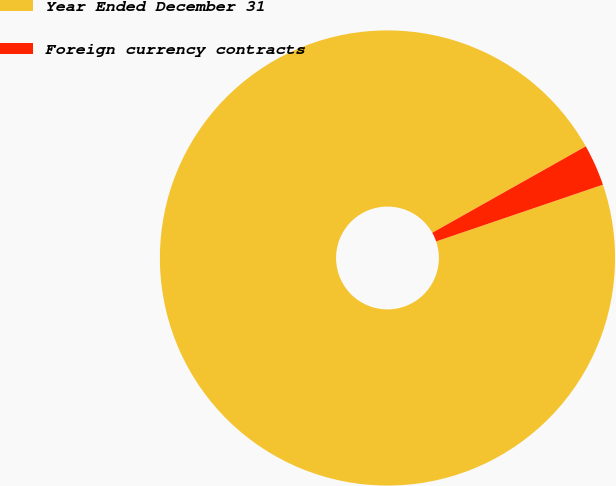Convert chart to OTSL. <chart><loc_0><loc_0><loc_500><loc_500><pie_chart><fcel>Year Ended December 31<fcel>Foreign currency contracts<nl><fcel>97.06%<fcel>2.94%<nl></chart> 